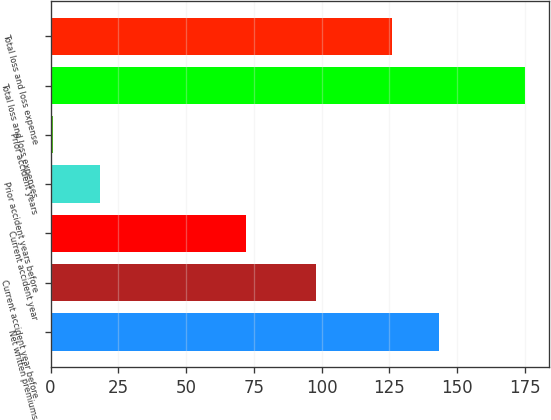Convert chart. <chart><loc_0><loc_0><loc_500><loc_500><bar_chart><fcel>Net written premiums<fcel>Current accident year before<fcel>Current accident year<fcel>Prior accident years before<fcel>Prior accident years<fcel>Total loss and loss expenses<fcel>Total loss and loss expense<nl><fcel>143.4<fcel>98<fcel>72<fcel>18.4<fcel>1<fcel>175<fcel>126<nl></chart> 